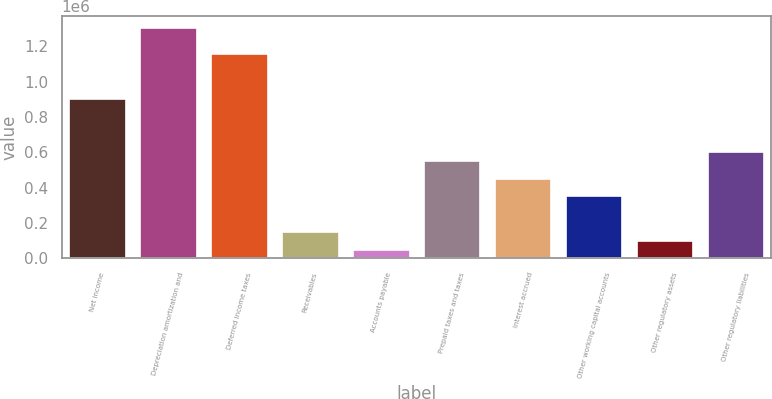Convert chart to OTSL. <chart><loc_0><loc_0><loc_500><loc_500><bar_chart><fcel>Net income<fcel>Depreciation amortization and<fcel>Deferred income taxes<fcel>Receivables<fcel>Accounts payable<fcel>Prepaid taxes and taxes<fcel>Interest accrued<fcel>Other working capital accounts<fcel>Other regulatory assets<fcel>Other regulatory liabilities<nl><fcel>904542<fcel>1.30655e+06<fcel>1.1558e+06<fcel>150780<fcel>50278.8<fcel>552787<fcel>452285<fcel>351784<fcel>100530<fcel>603038<nl></chart> 